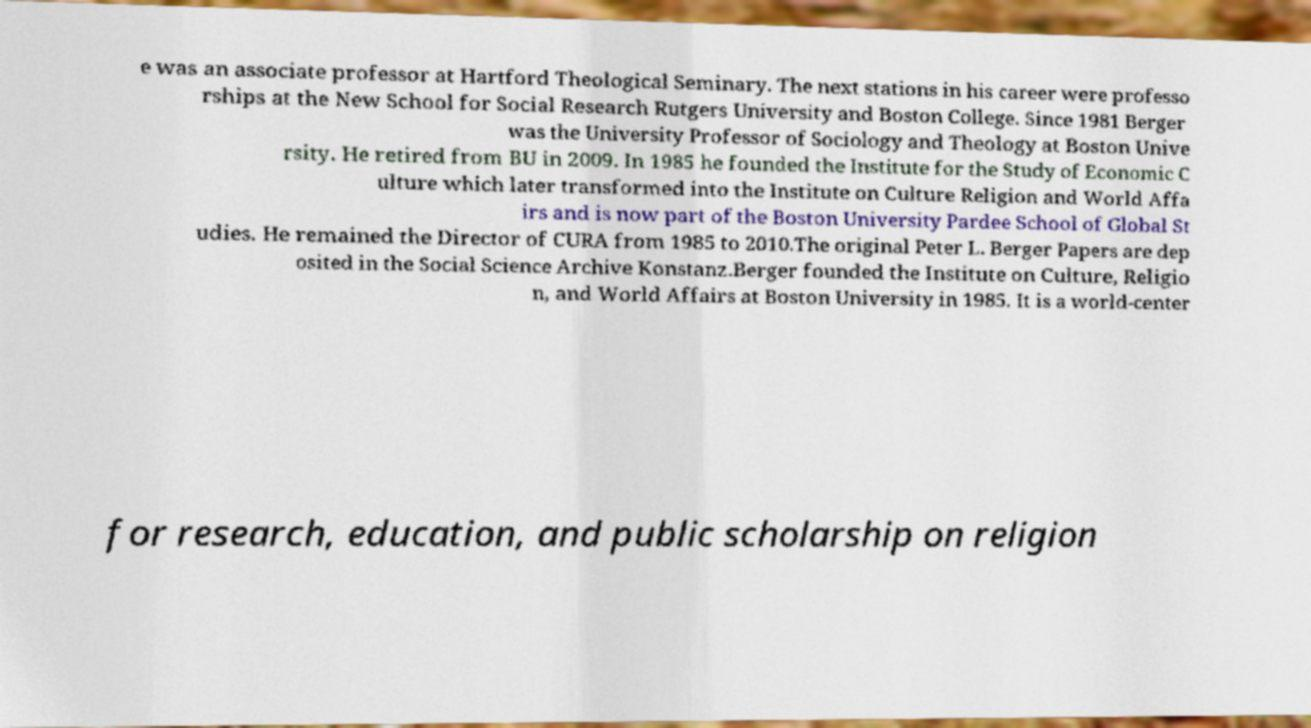There's text embedded in this image that I need extracted. Can you transcribe it verbatim? e was an associate professor at Hartford Theological Seminary. The next stations in his career were professo rships at the New School for Social Research Rutgers University and Boston College. Since 1981 Berger was the University Professor of Sociology and Theology at Boston Unive rsity. He retired from BU in 2009. In 1985 he founded the Institute for the Study of Economic C ulture which later transformed into the Institute on Culture Religion and World Affa irs and is now part of the Boston University Pardee School of Global St udies. He remained the Director of CURA from 1985 to 2010.The original Peter L. Berger Papers are dep osited in the Social Science Archive Konstanz.Berger founded the Institute on Culture, Religio n, and World Affairs at Boston University in 1985. It is a world-center for research, education, and public scholarship on religion 